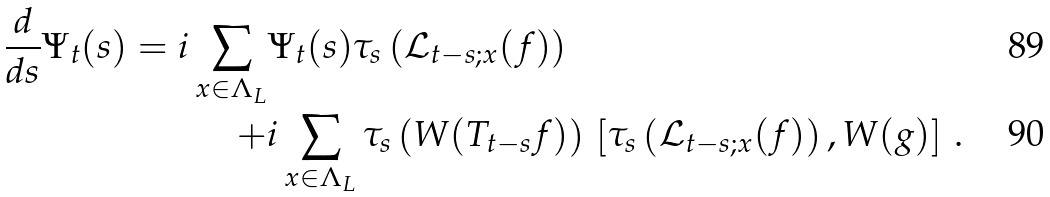<formula> <loc_0><loc_0><loc_500><loc_500>\frac { d } { d s } \Psi _ { t } ( s ) = i \sum _ { x \in \Lambda _ { L } } & \Psi _ { t } ( s ) \tau _ { s } \left ( \mathcal { L } _ { t - s ; x } ( f ) \right ) \\ + & i \sum _ { x \in \Lambda _ { L } } \tau _ { s } \left ( W ( T _ { t - s } f ) \right ) \, \left [ \tau _ { s } \left ( \mathcal { L } _ { t - s ; x } ( f ) \right ) , W ( g ) \right ] \, .</formula> 